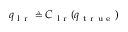<formula> <loc_0><loc_0><loc_500><loc_500>q _ { l r } \triangle q C _ { l r } ( q _ { t r u e } )</formula> 